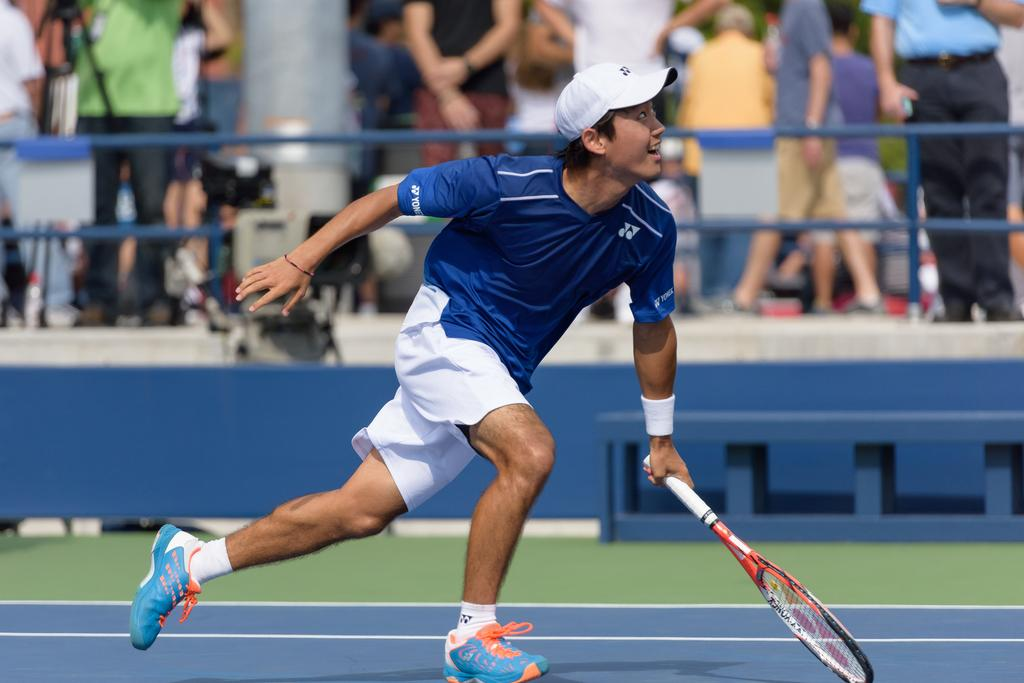What is the man in the image doing? The man is playing tennis. What object is the man holding in the image? The man is holding a tennis racket. Where is the scene taking place? The scene takes place in a tennis court. Are there any spectators in the image? Yes, there are people standing and watching. What is the purpose of the camera visible in the image? The camera might be used to capture the tennis match. What type of books can be seen on the farmer's shelf in the image? There is no farmer or bookshelf present in the image; it features a man playing tennis in a tennis court. 